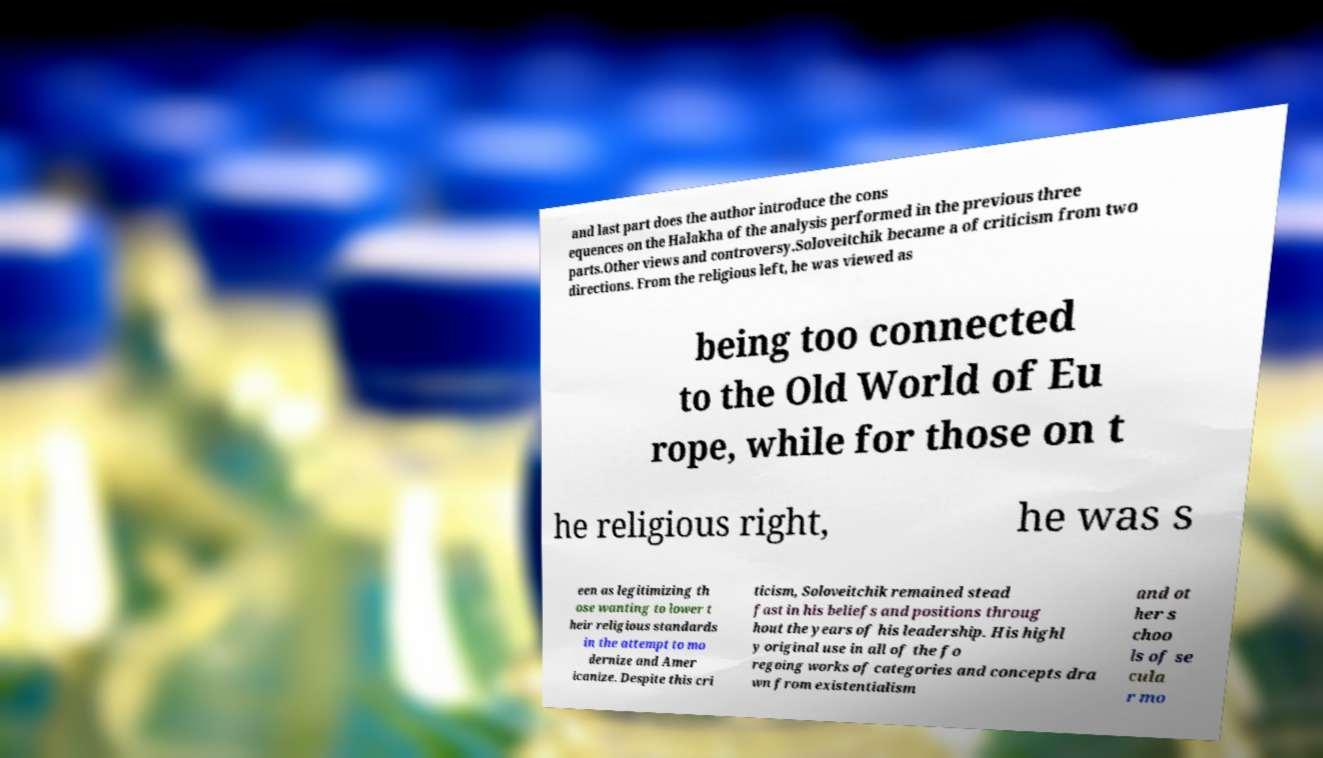There's text embedded in this image that I need extracted. Can you transcribe it verbatim? and last part does the author introduce the cons equences on the Halakha of the analysis performed in the previous three parts.Other views and controversy.Soloveitchik became a of criticism from two directions. From the religious left, he was viewed as being too connected to the Old World of Eu rope, while for those on t he religious right, he was s een as legitimizing th ose wanting to lower t heir religious standards in the attempt to mo dernize and Amer icanize. Despite this cri ticism, Soloveitchik remained stead fast in his beliefs and positions throug hout the years of his leadership. His highl y original use in all of the fo regoing works of categories and concepts dra wn from existentialism and ot her s choo ls of se cula r mo 